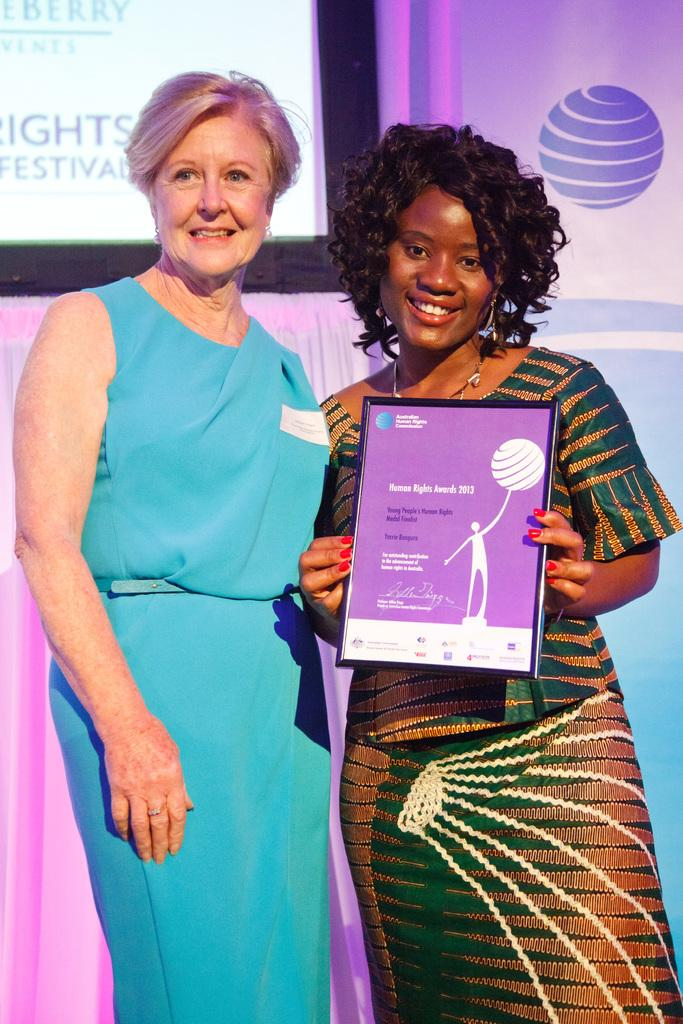How many people are in the image? There are people standing in the image. What is one person holding in the image? One person is holding a frame with a poster. What can be seen in the background of the image? There is a screen visible in the background of the image. How many stitches are visible on the girl's dress in the image? There is no girl or dress present in the image, so it is not possible to determine the number of stitches. 